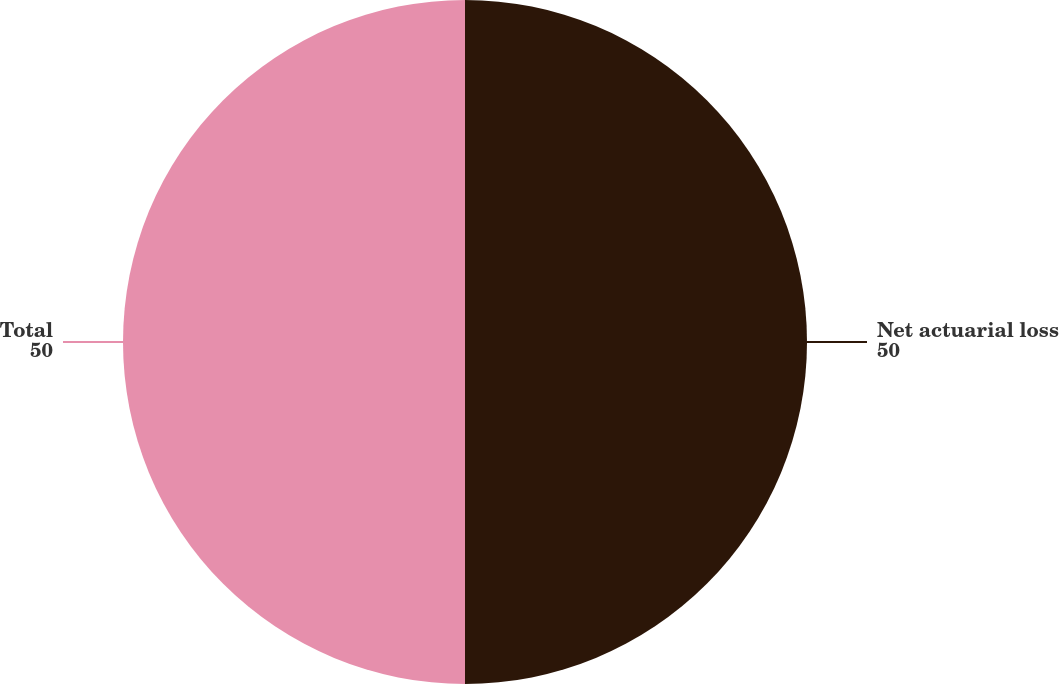Convert chart. <chart><loc_0><loc_0><loc_500><loc_500><pie_chart><fcel>Net actuarial loss<fcel>Total<nl><fcel>50.0%<fcel>50.0%<nl></chart> 